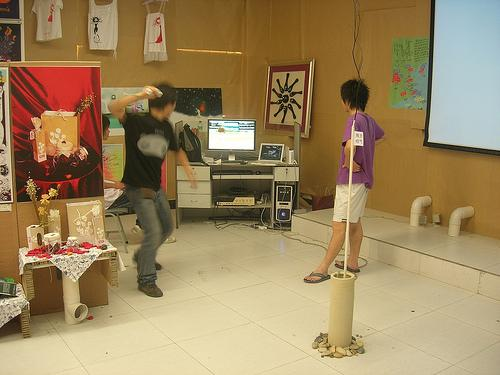Provide a brief description of the person's footwear and the position of their feet. The person is wearing sandals with their feet pointed in different directions. Mention the primary object or person in the image along with their apparel. A person wearing white shorts, a purple t-shirt, and sandals is standing in the image. What is the unique furniture piece in the image, and what is its primary feature? A table in the image has a plastic pipe serving as one of its legs. Describe the peculiar structure made of pipes in the image. Pipes on a platform are connected to the wall, with two white pipings coming out of the wall. Mention any activity involving people and electronics in the image. People are engaging with an electronic game, watching a TV screen. Describe any notable objects that are black and white in color. There are white garments hanging against the wall, and a picture of black objects swirling in a circle. Give a concise description of a computer component and its specifics. There is a good sized computer screen on the table, which is turned on. Describe any artwork or painting in the image along with its distinguishing characteristic. There is a painting of still life with a red background hanging on the wall. What unique item consists of multiple components, and what is the pattern of its arrangement? Rocks are arranged in a circle in the image. Briefly describe the computer-related objects and their arrangement in the image. There is a computer desk with a monitor, a desktop PC, and a laptop, as well as a black backpack and various electronic equipment. Is the person in the image wearing a yellow dress and black shoes? The person is actually wearing white shorts, a purple t-shirt, and sandals, not a yellow dress and black shoes. Are the shelves filled with books to the left of the painting? No, it's not mentioned in the image. 